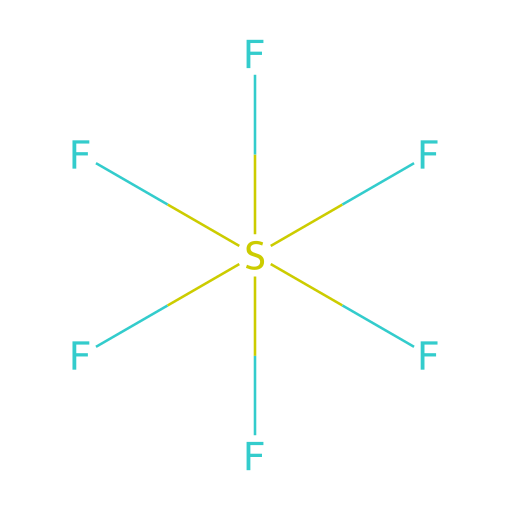What is the molecular formula of this compound? The given SMILES representation indicates one sulfur atom and six fluorine atoms. The molecular formula can be derived by counting these atoms: S for sulfur and F6 for six fluorine atoms.
Answer: SF6 How many bonds does the sulfur atom form in this compound? Each fluorine atom is bonded to the sulfur atom, and since there are six fluorine atoms, the sulfur forms six single bonds with them.
Answer: 6 What type of hybridization is present in the sulfur atom of this compound? To determine hybridization, we look at the total number of sigma bonds and lone pairs around the sulfur atom. With six single bonds and no lone pairs, it corresponds to sp3d2 hybridization.
Answer: sp3d2 What is a notable physical property of sulfur hexafluoride? Sulfur hexafluoride is known for being a very dense gas, which is relevant for its application in audio equipment to enhance acoustic properties.
Answer: dense gas Is sulfur hexafluoride polar or nonpolar? The symmetrical distribution of fluorine atoms around the sulfur atom results in a nonpolar molecular geometry, which means the overall polarity is zero.
Answer: nonpolar What is a common use of sulfur hexafluoride in high-end audio equipment? It is often used as an insulator in audio equipment because its properties allow for improved sound transmission and reduced noise interference.
Answer: insulator What is the state of sulfur hexafluoride at room temperature? At room temperature, sulfur hexafluoride is a gas due to its molecular structure and properties.
Answer: gas 